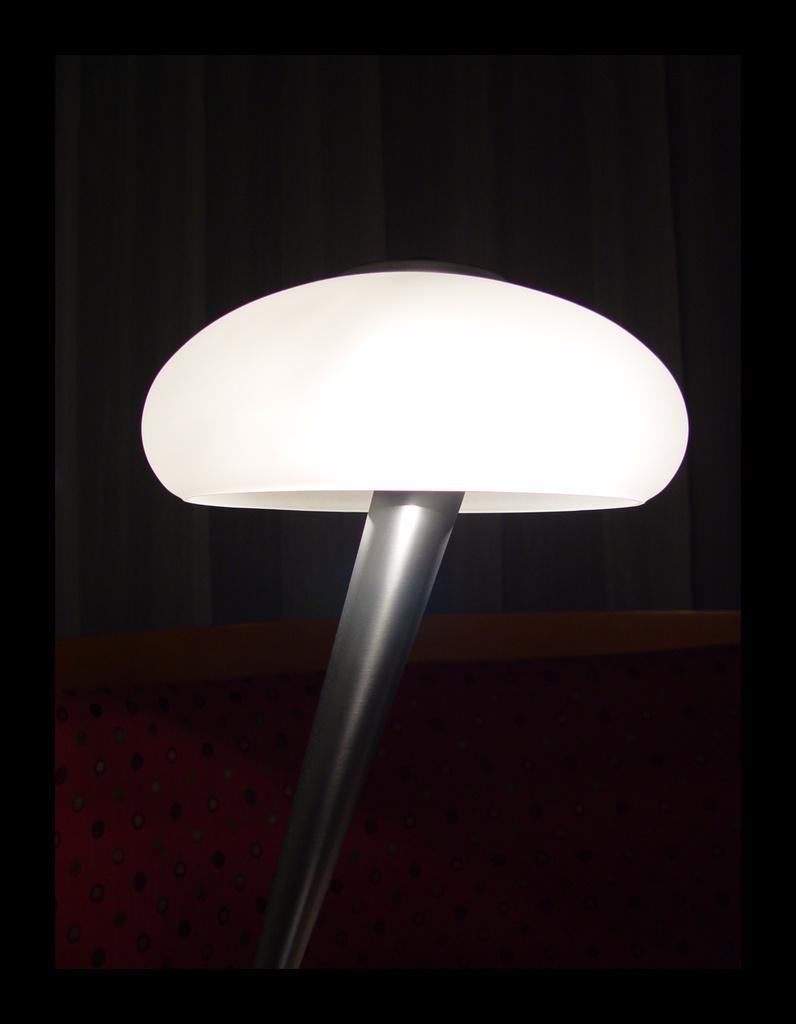What is the main object in the image? There is an object in the image, but its specific nature is not mentioned in the facts. What type of covering is present in the image? There is a curtain in the image. What type of furniture is visible in the image? There is a sofa in the image. What type of liquid is being poured through the channel in the image? There is no mention of a liquid or a channel in the image, so this question cannot be answered definitively. 